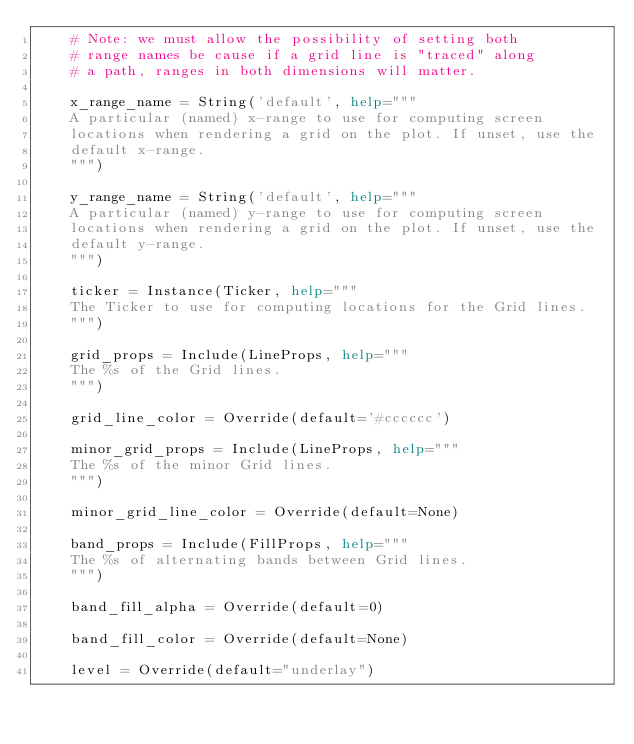Convert code to text. <code><loc_0><loc_0><loc_500><loc_500><_Python_>    # Note: we must allow the possibility of setting both
    # range names be cause if a grid line is "traced" along
    # a path, ranges in both dimensions will matter.

    x_range_name = String('default', help="""
    A particular (named) x-range to use for computing screen
    locations when rendering a grid on the plot. If unset, use the
    default x-range.
    """)

    y_range_name = String('default', help="""
    A particular (named) y-range to use for computing screen
    locations when rendering a grid on the plot. If unset, use the
    default y-range.
    """)

    ticker = Instance(Ticker, help="""
    The Ticker to use for computing locations for the Grid lines.
    """)

    grid_props = Include(LineProps, help="""
    The %s of the Grid lines.
    """)

    grid_line_color = Override(default='#cccccc')

    minor_grid_props = Include(LineProps, help="""
    The %s of the minor Grid lines.
    """)

    minor_grid_line_color = Override(default=None)

    band_props = Include(FillProps, help="""
    The %s of alternating bands between Grid lines.
    """)

    band_fill_alpha = Override(default=0)

    band_fill_color = Override(default=None)

    level = Override(default="underlay")
</code> 